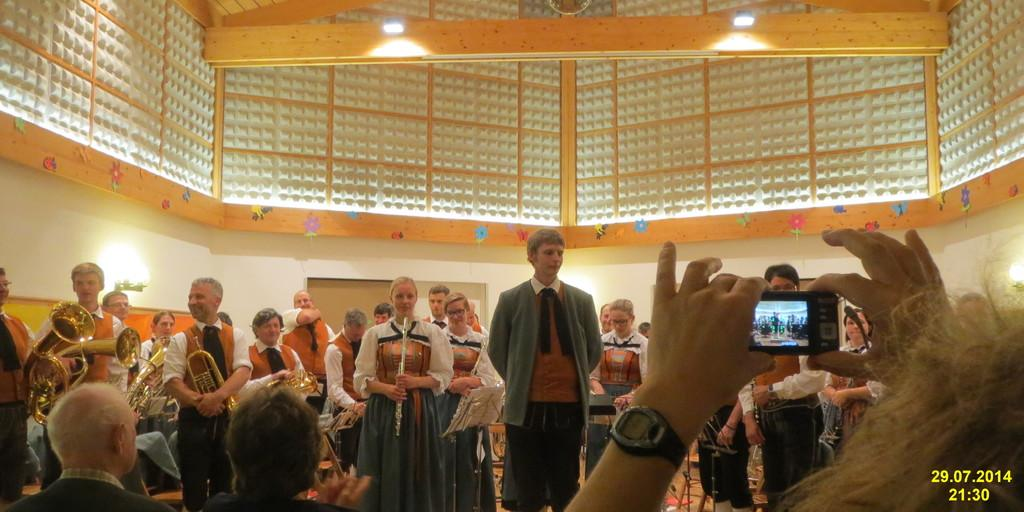Provide a one-sentence caption for the provided image. The video shown of this crowd was recorded at 21.30. 